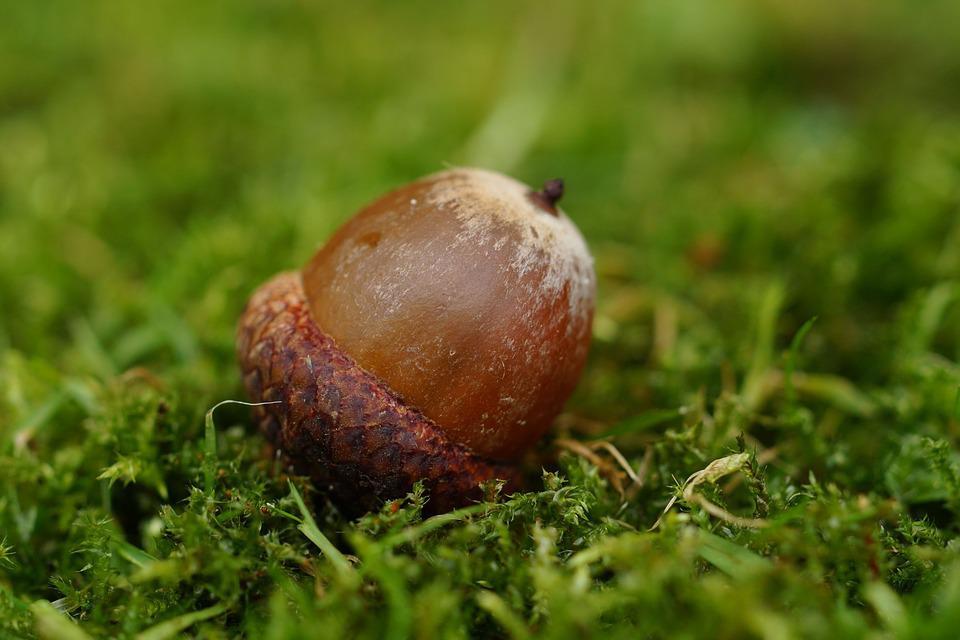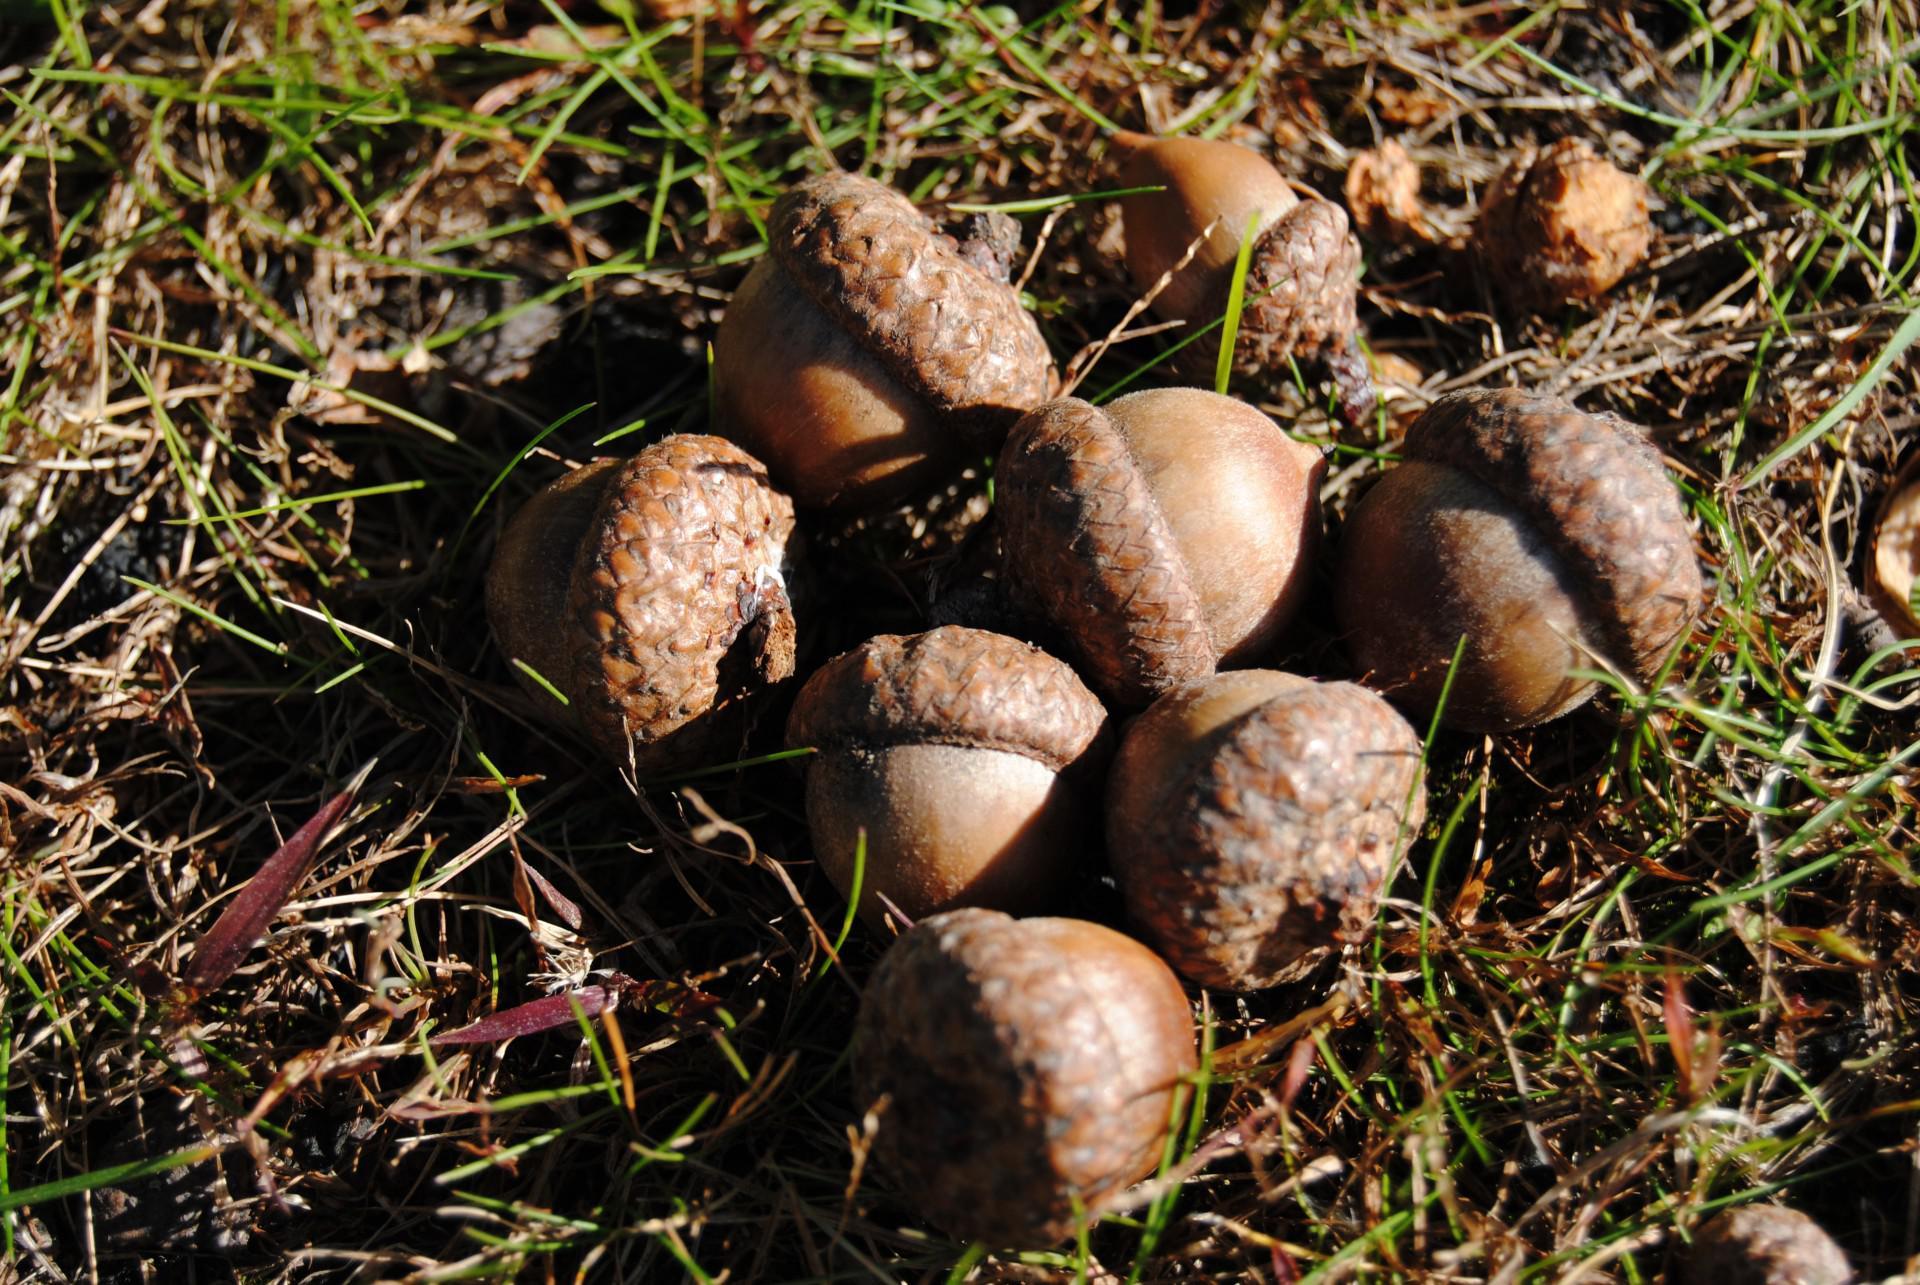The first image is the image on the left, the second image is the image on the right. For the images shown, is this caption "One image shows exactly two brown acorns in back-to-back caps on green foliage." true? Answer yes or no. No. The first image is the image on the left, the second image is the image on the right. For the images displayed, is the sentence "in at least one image there are two of acorns attached together." factually correct? Answer yes or no. No. 